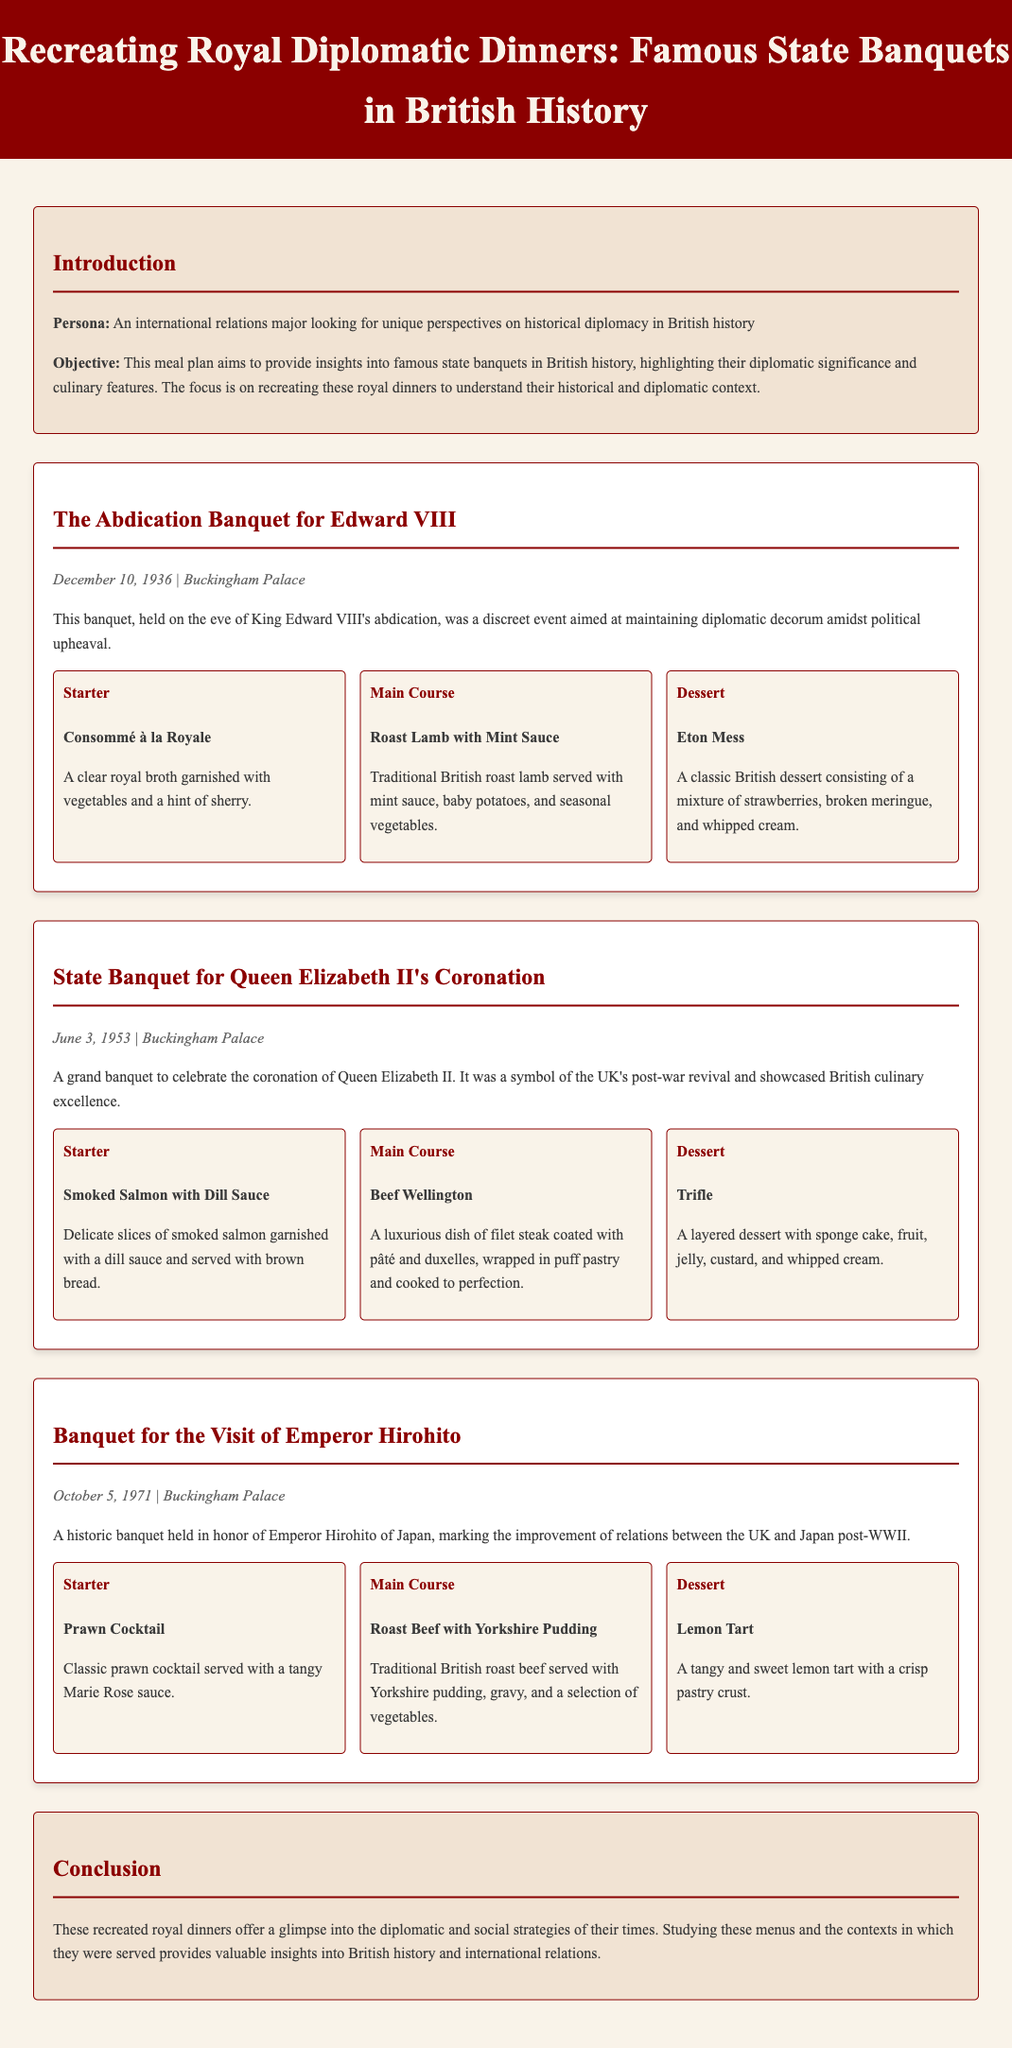what was the date of the Abdication Banquet for Edward VIII? The document states that the Abdication Banquet took place on December 10, 1936.
Answer: December 10, 1936 what was served as the main course at Queen Elizabeth II's Coronation Banquet? The main course for the state banquet was Beef Wellington.
Answer: Beef Wellington who was honored at the banquet on October 5, 1971? The document mentions that Emperor Hirohito of Japan was the guest of honor at this banquet.
Answer: Emperor Hirohito what dessert was served at the Abdication Banquet for Edward VIII? The dessert mentioned for the Abdication Banquet is Eton Mess.
Answer: Eton Mess how many different banquets are detailed in the document? The document details three different royal banquets.
Answer: Three why was the State Banquet for Queen Elizabeth II significant? This banquet symbolized the UK's post-war revival and showcased British culinary excellence.
Answer: Post-war revival which dish accompanied the Starter known as Smoked Salmon? The dish was garnished with a dill sauce and served with brown bread.
Answer: Dill sauce and brown bread what culinary feature is highlighted in the conclusion of the document? The conclusion points out that studying the menus and contexts provides valuable insights into British history and international relations.
Answer: Valuable insights into British history and international relations 